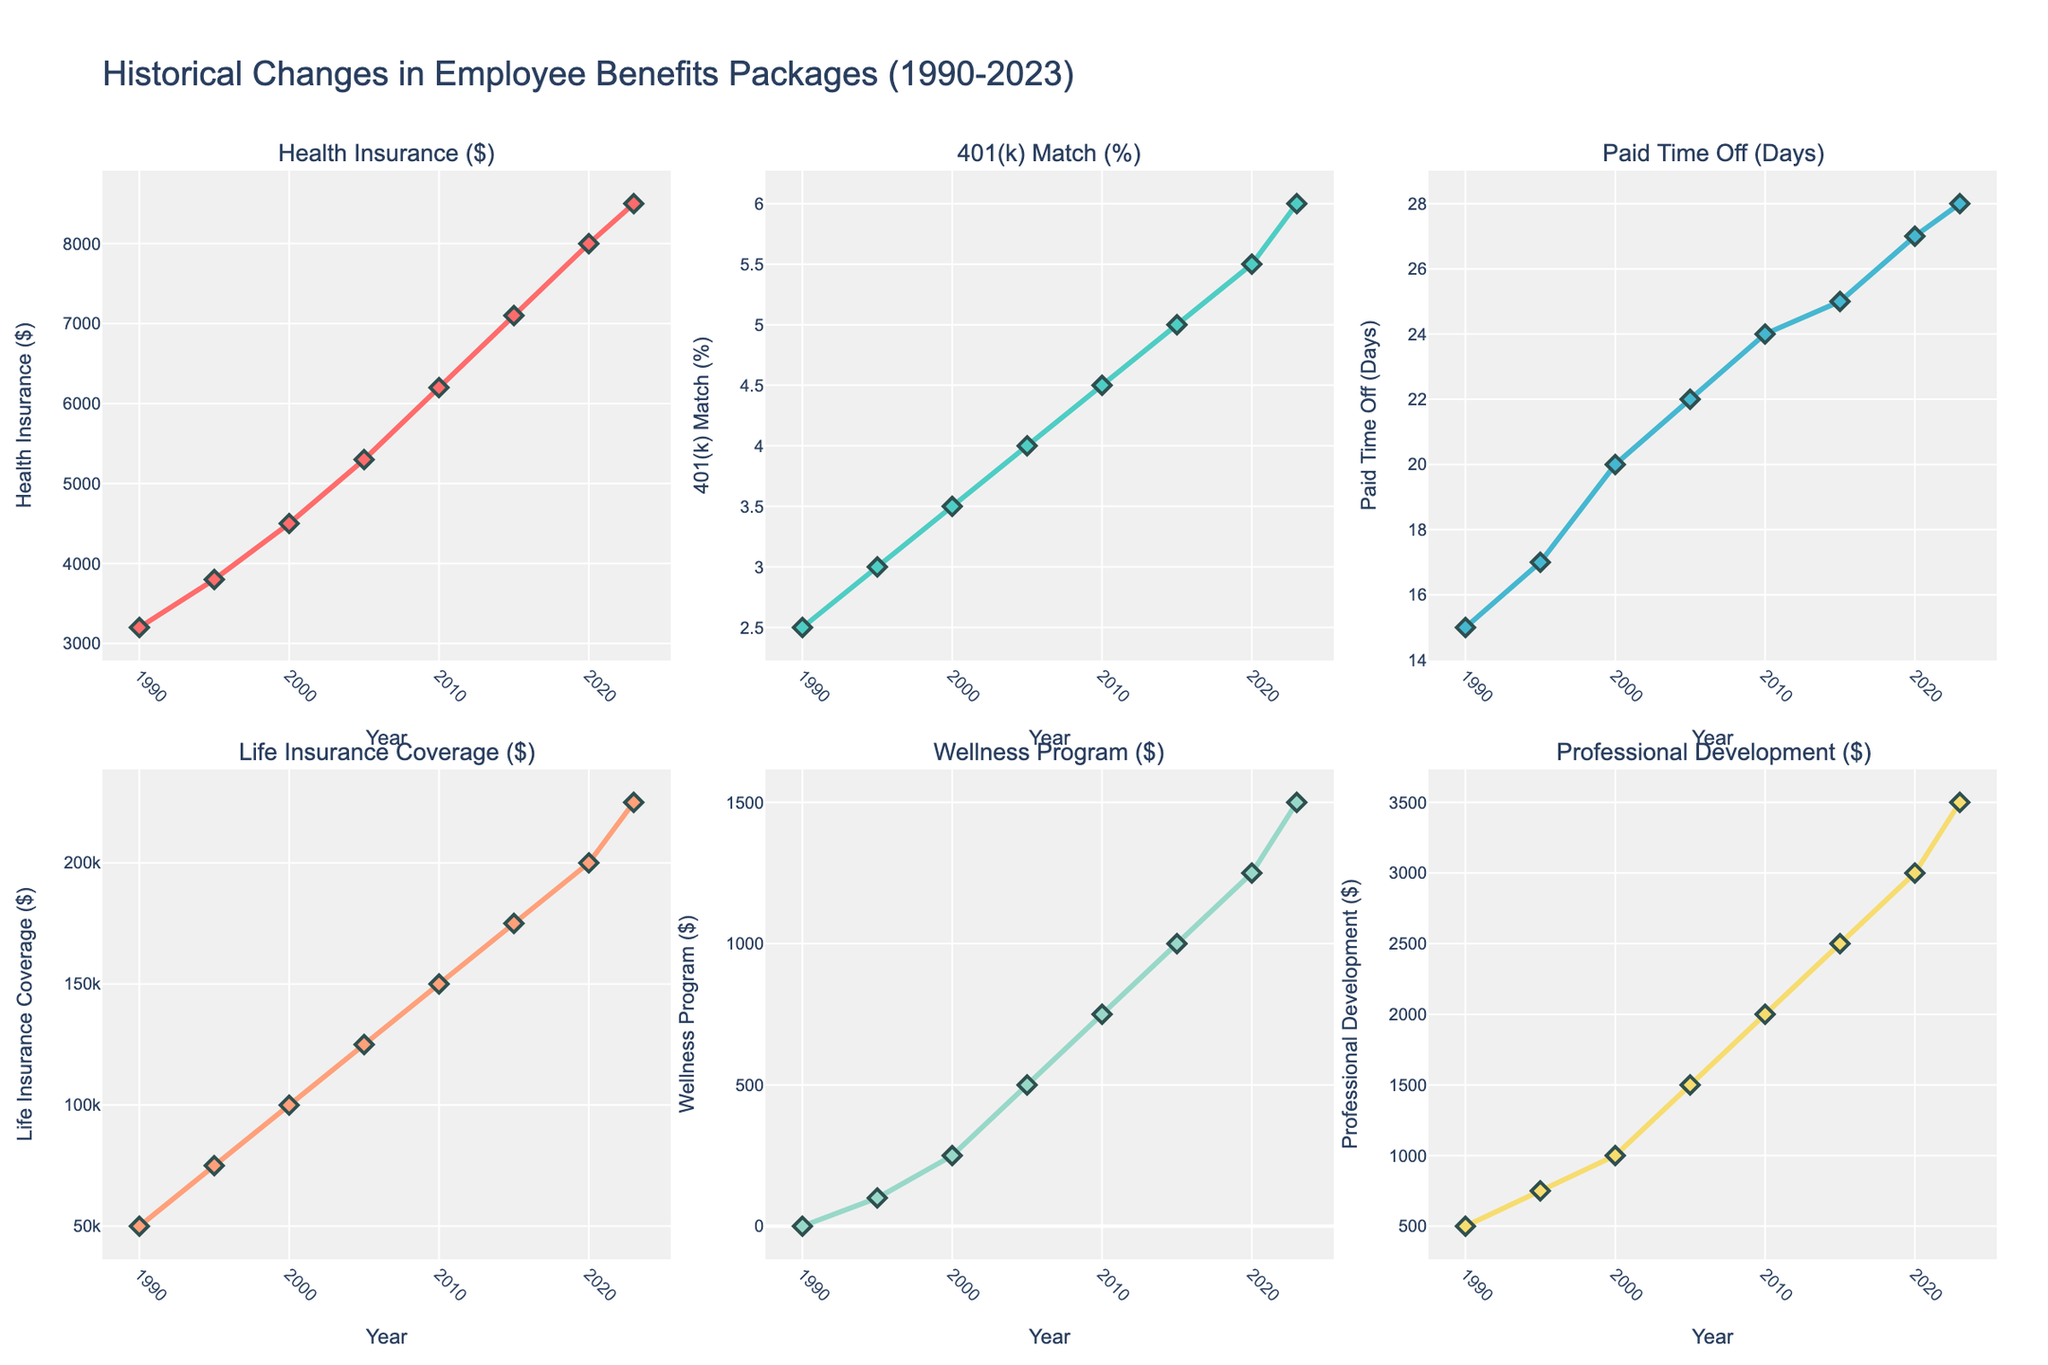What was the value of Health Insurance in 2000, and how much did it increase by 2023? In 2000, the Health Insurance value was $4,500. By 2023, it had increased to $8,500. So, the increase is calculated as $8,500 - $4,500 = $4,000.
Answer: $4,000 How much did the Life Insurance Coverage increase from 1990 to 2023? The Life Insurance Coverage in 1990 was $50,000 and increased to $225,000 by 2023. The increment is $225,000 - $50,000 = $175,000.
Answer: $175,000 By how many days did Paid Time Off change from 1995 to 2010? In 1995, Paid Time Off was 17 days, and in 2010, it was 24 days. The change is 24 - 17 = 7 days.
Answer: 7 days Which benefits package value showed the highest increase in monetary value between 2000 and 2015? By examining the figure, Health Insurance rose from $4,500 to $7,100 (an increase of $2,600), Life Insurance Coverage rose from $100,000 to $175,000 (an increase of $75,000), and Professional Development from $1,000 to $2,500 (an increase of $1,500). Life Insurance shows the highest increase.
Answer: Life Insurance Coverage What is the average annual increment in 401(k) Match (%) from 2000 to 2010? The 401(k) Match % in 2000 was 3.5% and in 2010 was 4.5%. The total increment over 10 years is 4.5% - 3.5% = 1%. The average annual increment is 1% / 10 = 0.1%.
Answer: 0.1% Which benefits package saw a consistent increase every year? Examining the figure, all benefits seem to show a consistent increase year to year, but Health Insurance and Life Insurance Coverage clearly show a steady yearly rise without any years of decline.
Answer: Health Insurance, Life Insurance Coverage What was the numerical value of Wellness Program in 2015, and what is the percentage increase by 2023? The Wellness Program value was $1,000 in 2015 and went up to $1,500 by 2023. The percentage increase is calculated as ($1,500 - $1,000) / $1,000 * 100% = 50%.
Answer: 50% By what amount did Professional Development funding increase per year on average between 2010 and 2023? The Professional Development funding increased from $2,000 to $3,500 over 13 years (from 2010 to 2023). The increment is $3,500 - $2,000 = $1,500. The average per year increment is $1,500 / 13 ≈ $115.38.
Answer: $115.38 